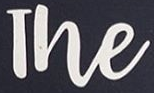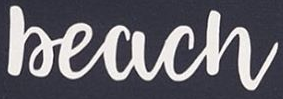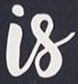What text is displayed in these images sequentially, separated by a semicolon? The; Beach; Is 